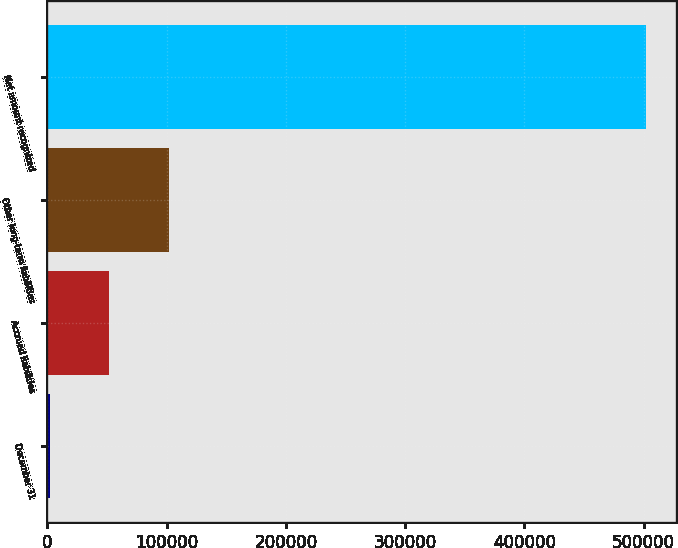Convert chart to OTSL. <chart><loc_0><loc_0><loc_500><loc_500><bar_chart><fcel>December 31<fcel>Accrued liabilities<fcel>Other long-term liabilities<fcel>Net amount recognized<nl><fcel>2005<fcel>51991.7<fcel>101978<fcel>501872<nl></chart> 